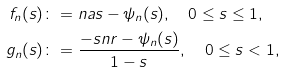Convert formula to latex. <formula><loc_0><loc_0><loc_500><loc_500>f _ { n } ( s ) & \colon = n a s - \psi _ { n } ( s ) , \quad 0 \leq s \leq 1 , \\ g _ { n } ( s ) & \colon = \frac { - s n r - \psi _ { n } ( s ) } { 1 - s } , \quad 0 \leq s < 1 ,</formula> 